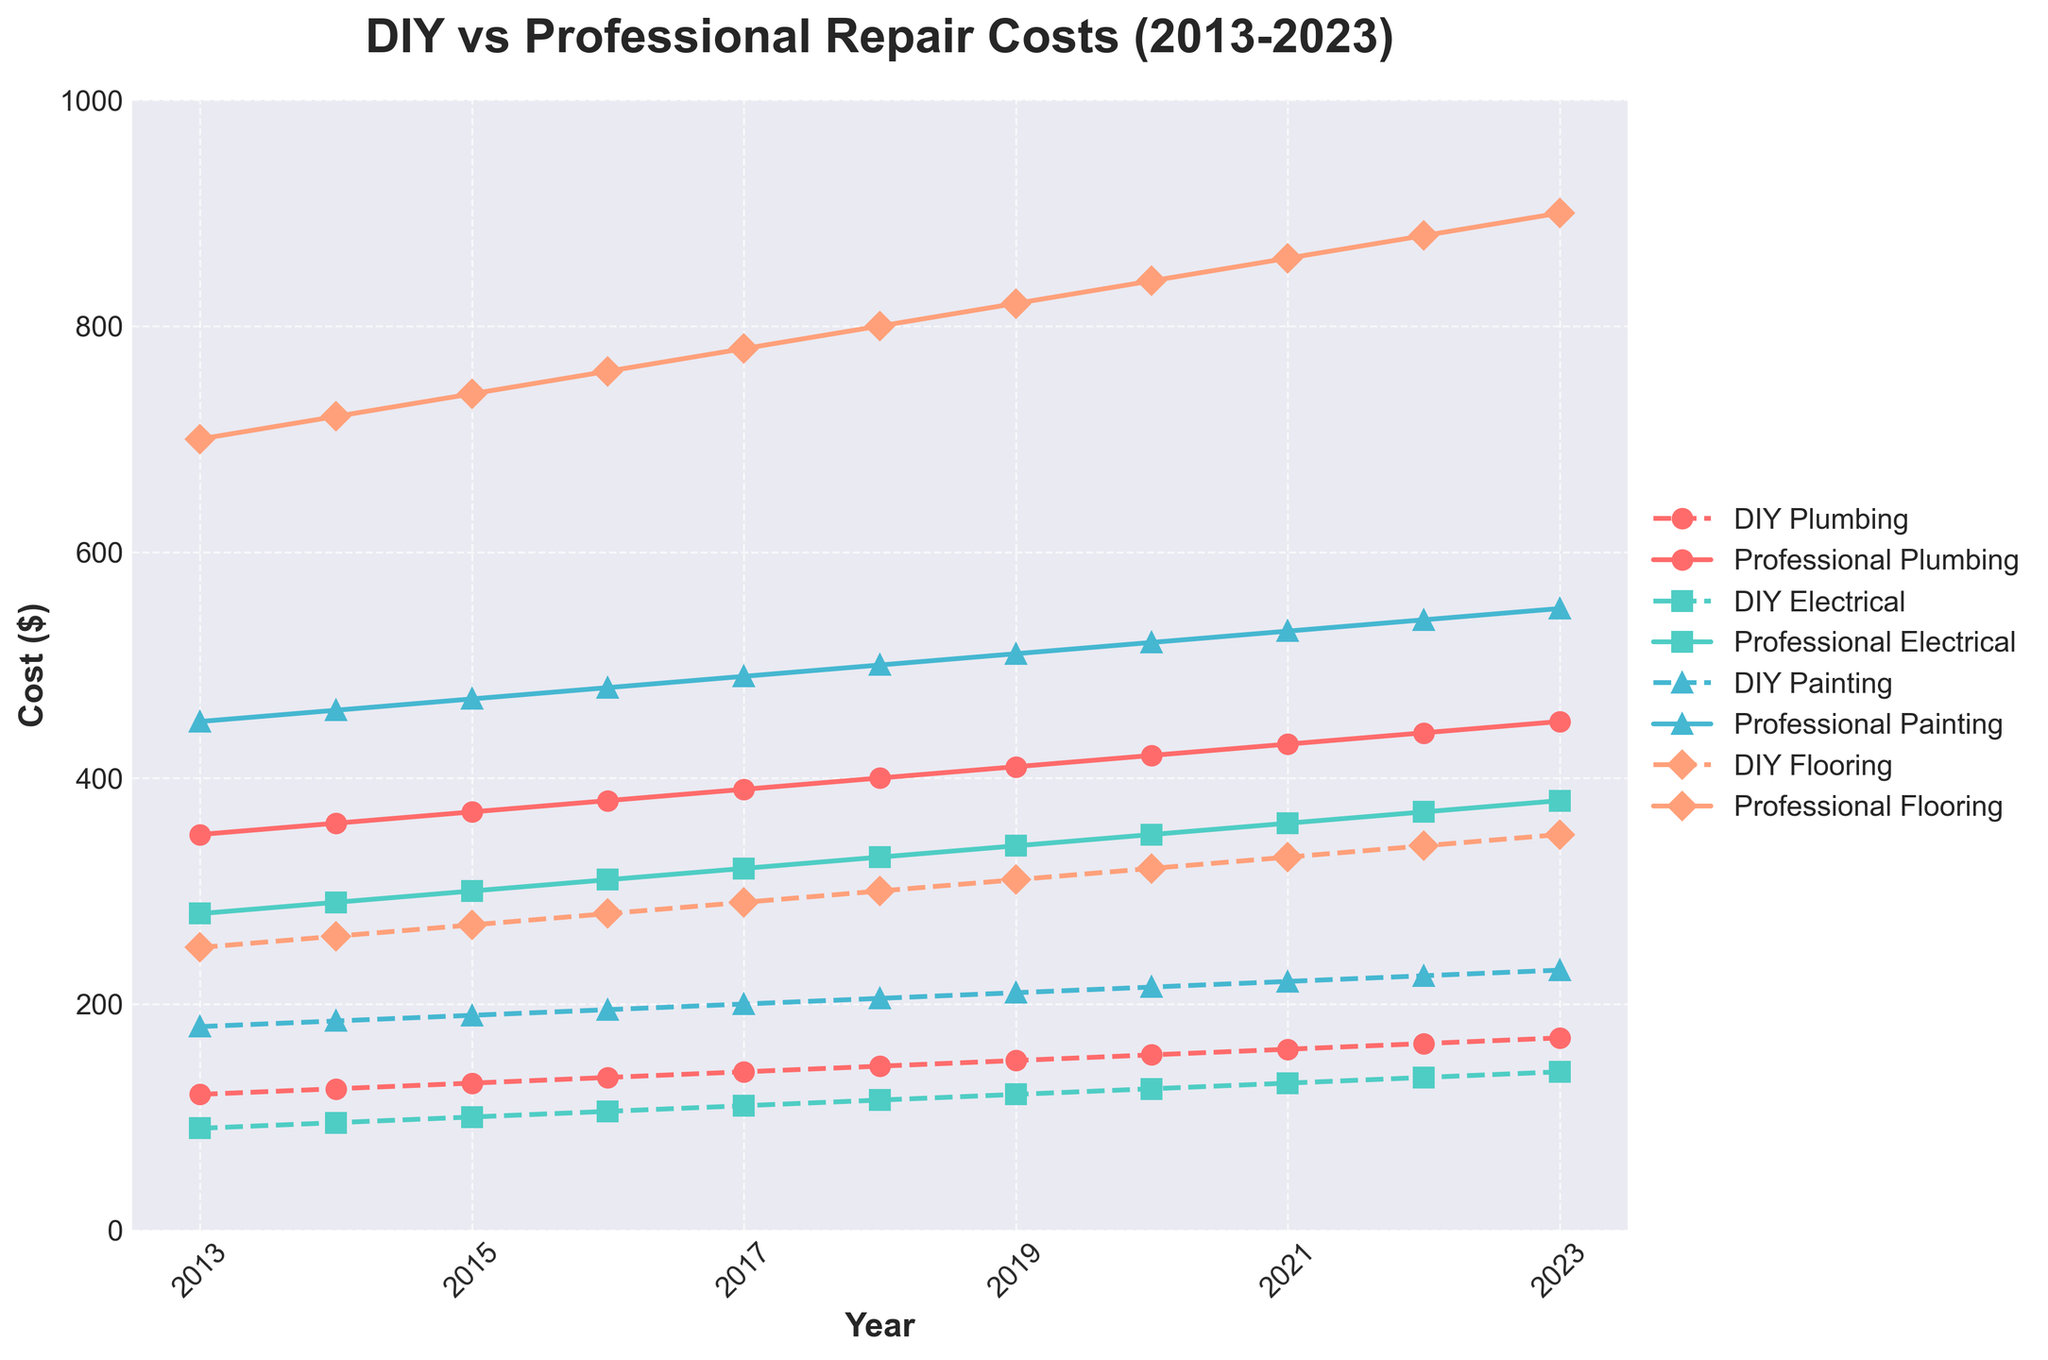How much did DIY painting cost in 2020? Look at the point for "DIY Painting" on the plot for the year 2020. From the visual, you can see the cost.
Answer: $215 What is the trend for professional plumbing costs from 2013 to 2023? Observe the line representing "Professional Plumbing" over the years from 2013 to 2023. The line is increasing, indicating a consistent rise in professional plumbing costs over this period.
Answer: Increasing How much more did professional flooring cost compared to DIY flooring in 2023? Identify the points for "Professional Flooring" and "DIY Flooring" in 2023. Subtract the DIY cost from the professional cost: $900 - $350 = $550.
Answer: $550 Between 2017 and 2019, which type of repair had the smallest increase in DIY costs? Calculate the increase for each DIY repair type between 2017 and 2019: 
    - DIY Plumbing: $150 - $140 = $10
    - DIY Electrical: $120 - $110 = $10
    - DIY Painting: $210 - $200 = $10
    - DIY Flooring: $310 - $290 = $20. 
The smallest increase is $10, which is the same for Plumbing, Electrical, and Painting.
Answer: Plumbing, Electrical, Painting Which year had the largest gap between DIY and professional electrical repair costs? Calculate the gap for each year by subtracting the DIY electrical cost from the professional electrical cost. Find the year with the largest difference: 
    - 2013: $280 - $90 = $190
    - 2014: $290 - $95 = $195
    - .....
    - 2023: $380 - $140 = $240. 
The largest gap occurs in 2023.
Answer: 2023 Which repair type had the highest DIY cost in 2015? Compare the costs of all DIY repair types in 2015:
    - Plumbing: $130
    - Electrical: $100
    - Painting: $190
    - Flooring: $270. 
Flooring has the highest DIY cost.
Answer: Flooring By how much percent did professional painting costs increase from 2013 to 2023? Calculate the percentage increase:
    - Initial cost in 2013: $450
    - Final cost in 2023: $550
    - Increase: $550 - $450 = $100
    - Percentage increase: ($100 / $450) * 100 = ~22.22%.
Answer: ~22.22% Which type of repair shows the steepest increase in DIY costs from 2013 to 2023? Observe the slope of each DIY repair line from 2013 to 2023. The line with the steepest increase represents the repair type with the greatest rise in costs. DIY Flooring shows the steepest increase.
Answer: Flooring 